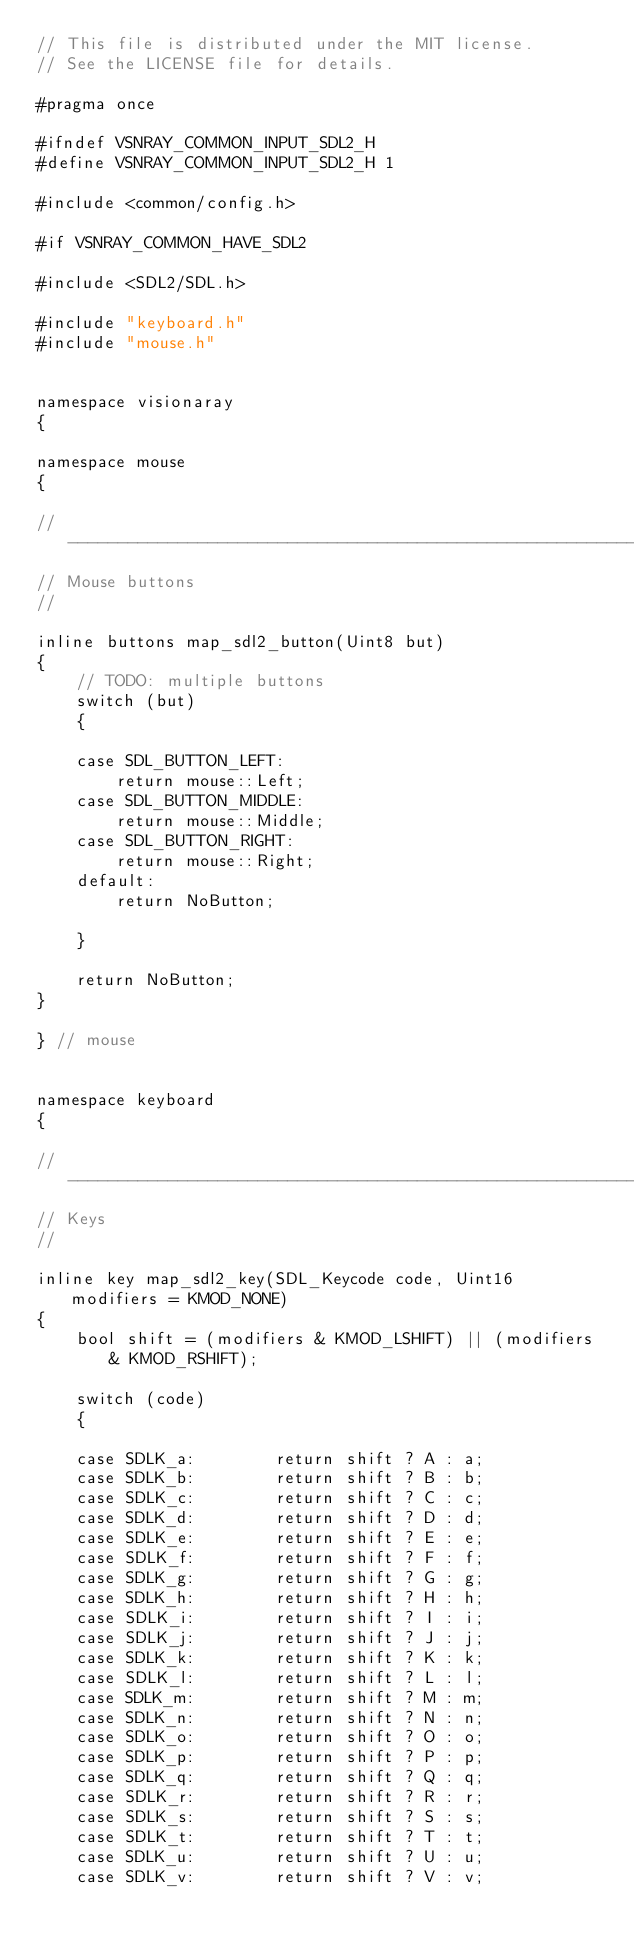<code> <loc_0><loc_0><loc_500><loc_500><_C_>// This file is distributed under the MIT license.
// See the LICENSE file for details.

#pragma once

#ifndef VSNRAY_COMMON_INPUT_SDL2_H
#define VSNRAY_COMMON_INPUT_SDL2_H 1

#include <common/config.h>

#if VSNRAY_COMMON_HAVE_SDL2

#include <SDL2/SDL.h>

#include "keyboard.h"
#include "mouse.h"


namespace visionaray
{

namespace mouse
{

//-------------------------------------------------------------------------------------------------
// Mouse buttons
//

inline buttons map_sdl2_button(Uint8 but)
{
    // TODO: multiple buttons
    switch (but)
    {

    case SDL_BUTTON_LEFT:
        return mouse::Left;
    case SDL_BUTTON_MIDDLE:
        return mouse::Middle;
    case SDL_BUTTON_RIGHT:
        return mouse::Right;
    default:
        return NoButton;

    }

    return NoButton;
}

} // mouse


namespace keyboard
{

//-------------------------------------------------------------------------------------------------
// Keys
//

inline key map_sdl2_key(SDL_Keycode code, Uint16 modifiers = KMOD_NONE)
{
    bool shift = (modifiers & KMOD_LSHIFT) || (modifiers & KMOD_RSHIFT);

    switch (code)
    {

    case SDLK_a:        return shift ? A : a;
    case SDLK_b:        return shift ? B : b;
    case SDLK_c:        return shift ? C : c;
    case SDLK_d:        return shift ? D : d;
    case SDLK_e:        return shift ? E : e;
    case SDLK_f:        return shift ? F : f;
    case SDLK_g:        return shift ? G : g;
    case SDLK_h:        return shift ? H : h;
    case SDLK_i:        return shift ? I : i;
    case SDLK_j:        return shift ? J : j;
    case SDLK_k:        return shift ? K : k;
    case SDLK_l:        return shift ? L : l;
    case SDLK_m:        return shift ? M : m;
    case SDLK_n:        return shift ? N : n;
    case SDLK_o:        return shift ? O : o;
    case SDLK_p:        return shift ? P : p;
    case SDLK_q:        return shift ? Q : q;
    case SDLK_r:        return shift ? R : r;
    case SDLK_s:        return shift ? S : s;
    case SDLK_t:        return shift ? T : t;
    case SDLK_u:        return shift ? U : u;
    case SDLK_v:        return shift ? V : v;</code> 